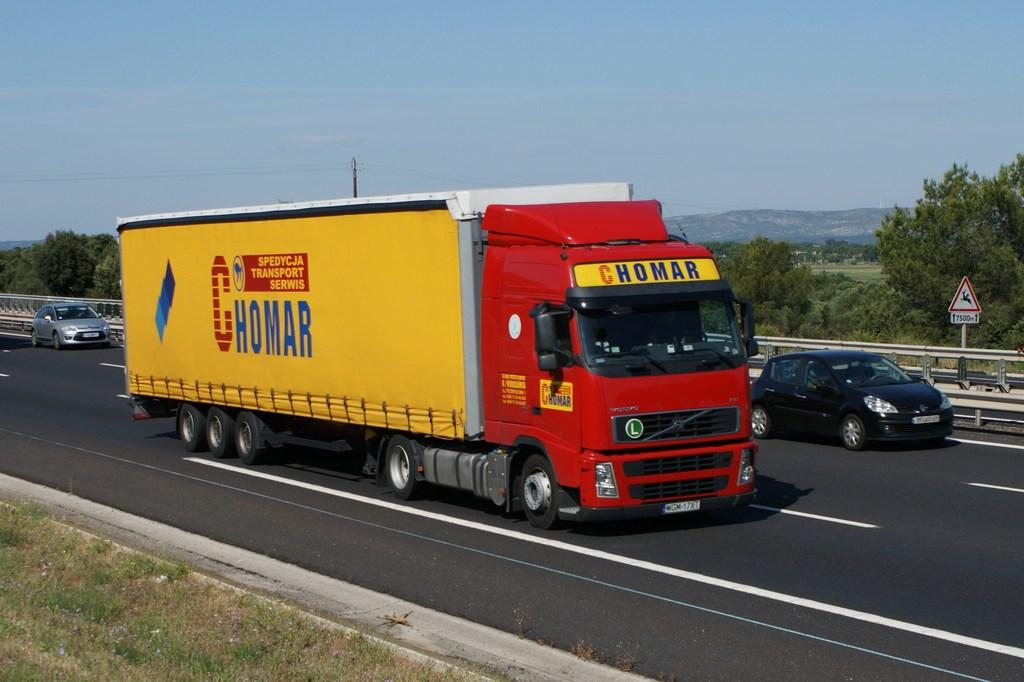What can be seen on the road in the image? There are vehicles on the road in the image. What type of natural elements are present in the image? There are trees, grass, and mountains in the image. What man-made structures can be seen in the image? There are poles, sign boards, and railing in the image. What is visible in the background of the image? The sky is visible in the background of the image. Can you tell me how many pieces of cake are on the hose in the image? There is no cake or hose present in the image. What type of offer is being made by the person in the image? There is no person or offer present in the image. 